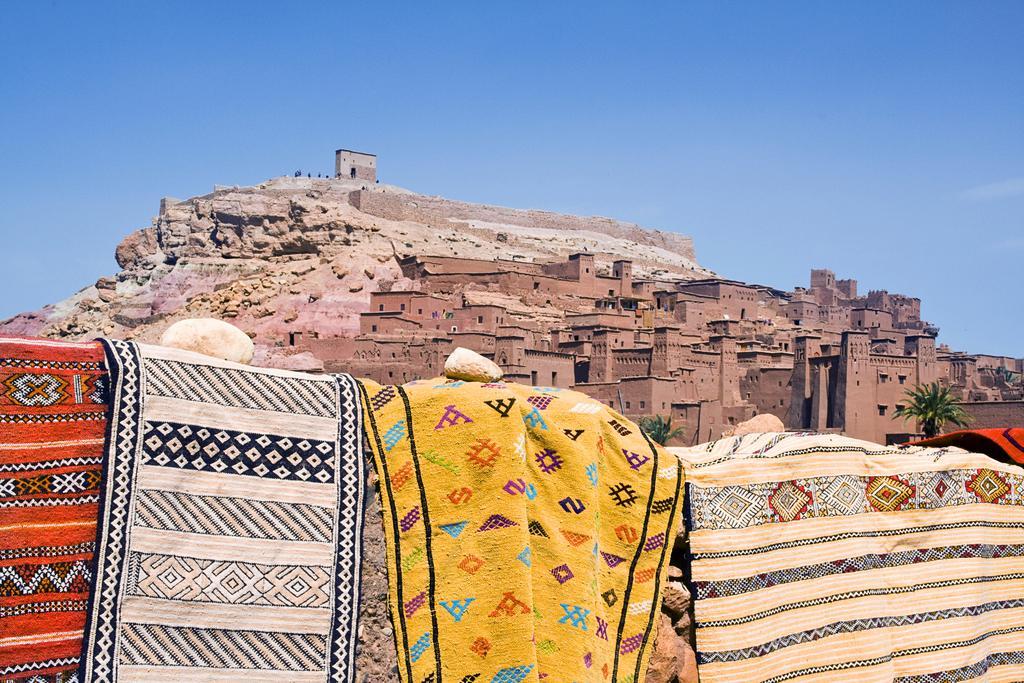Please provide a concise description of this image. In the image there are bed sheets on the wall and behind it there are many buildings on a mountain and above its sky. 